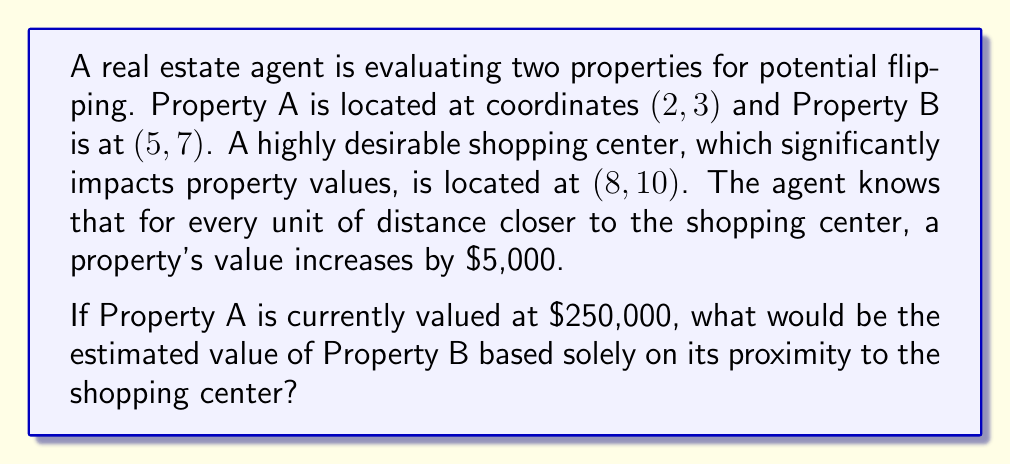Solve this math problem. To solve this problem, we'll follow these steps:

1) Calculate the distance from Property A to the shopping center using the distance formula:
   $$d_A = \sqrt{(x_2-x_1)^2 + (y_2-y_1)^2}$$
   $$d_A = \sqrt{(8-2)^2 + (10-3)^2} = \sqrt{36 + 49} = \sqrt{85} \approx 9.22$$

2) Calculate the distance from Property B to the shopping center:
   $$d_B = \sqrt{(8-5)^2 + (10-7)^2} = \sqrt{9 + 9} = \sqrt{18} \approx 4.24$$

3) Calculate the difference in distances:
   $$\text{Difference} = d_A - d_B \approx 9.22 - 4.24 \approx 4.98$$

4) Calculate the value increase for Property B:
   $$\text{Value Increase} = 4.98 \times \$5,000 \approx \$24,900$$

5) Add this increase to Property A's value to get Property B's estimated value:
   $$\text{Property B Value} = \$250,000 + \$24,900 = \$274,900$$
Answer: $274,900 